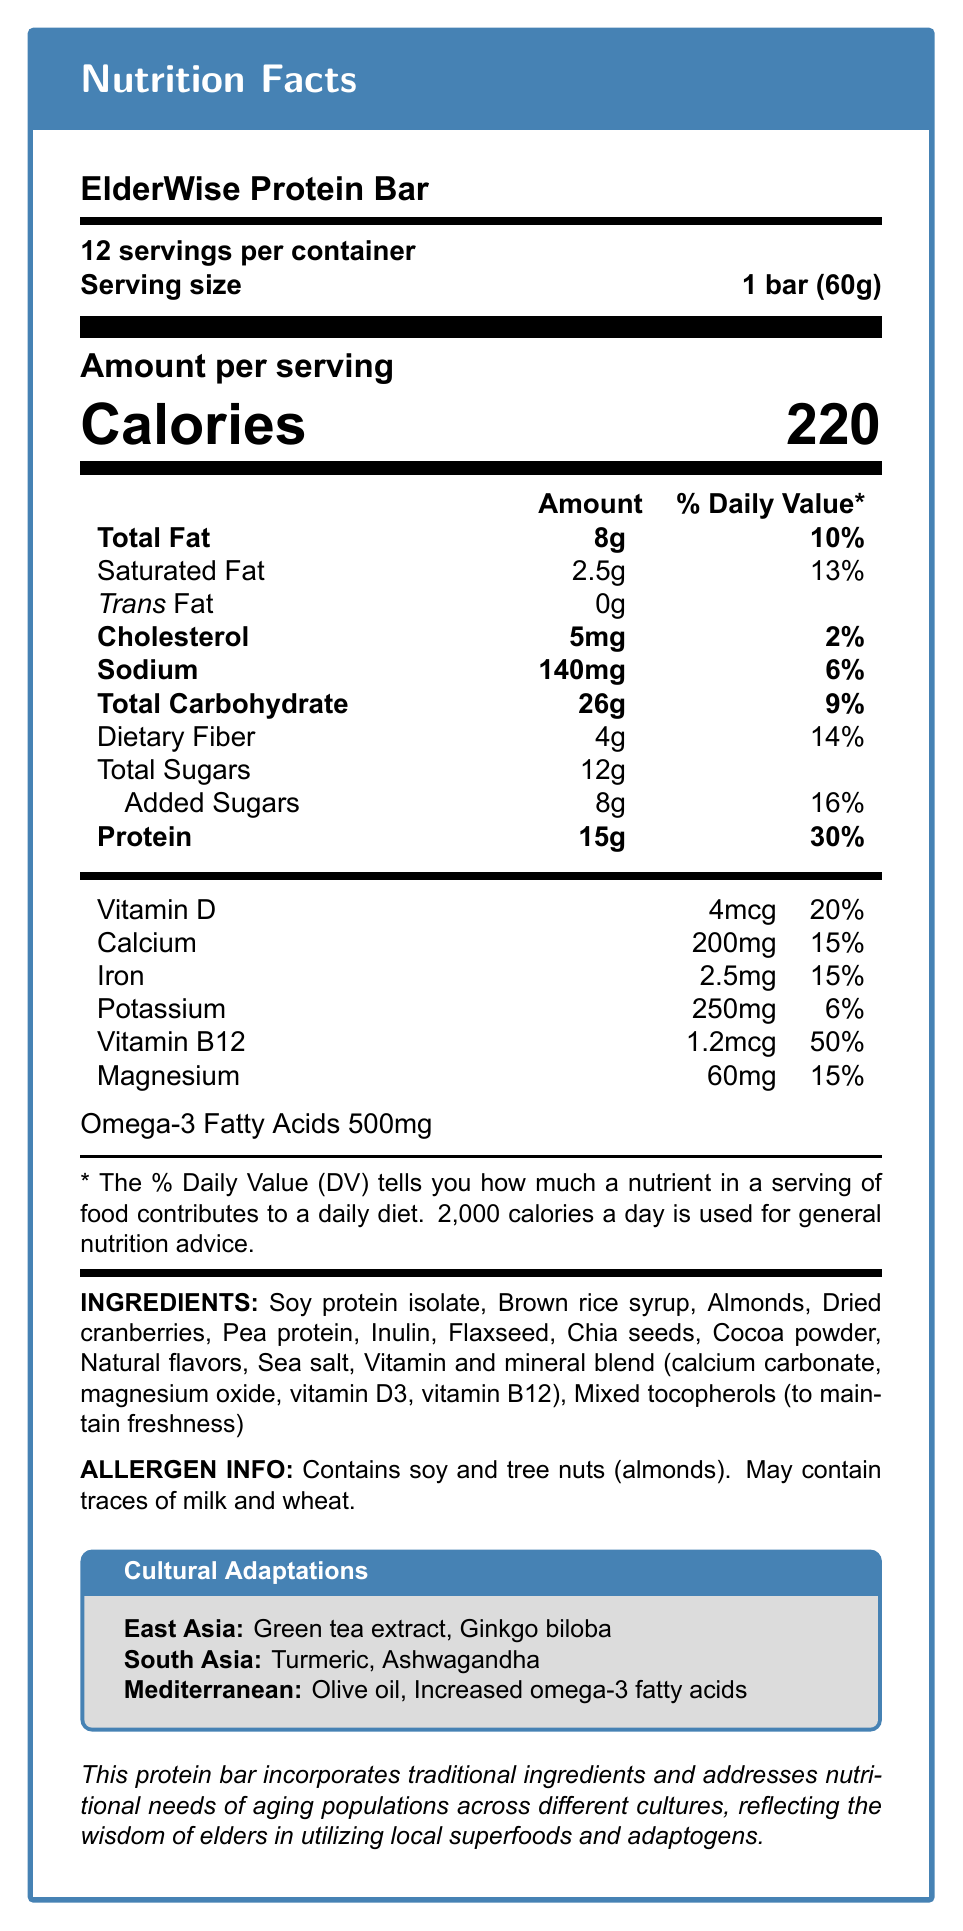what is the serving size of the ElderWise Protein Bar? The serving size is listed as "1 bar (60g)" in the document.
Answer: 1 bar (60g) how many servings are there per container? The document states that there are 12 servings per container.
Answer: 12 what is the total fat content per serving? The amount of total fat per serving is listed as 8g in the document.
Answer: 8g how much protein does each serving provide? The document specifies that each serving contains 15g of protein.
Answer: 15g what are the two allergens mentioned in the document? The allergen information section of the document lists soy and tree nuts (almonds) as allergens.
Answer: Soy and tree nuts (almonds) what are the cultural adaptations made for the East Asia region? The document specifies these adaptations under the cultural adaptations section for the East Asia region.
Answer: Green tea extract added for antioxidant properties, Ginkgo biloba for cognitive support what is the total amount of sugars per serving, including added sugars? The document lists total sugars as 12g and added sugars as 8g.
Answer: 12g total sugars, 8g added sugars what is the percentage of daily value for vitamin B12 per serving? The document states that one serving provides 50% of the daily value for vitamin B12.
Answer: 50% what ingredient is used to maintain freshness? The document lists mixed tocopherols as an ingredient for maintaining freshness.
Answer: Mixed tocopherols how many calories are there in one serving of the ElderWise Protein Bar? The document specifies that one serving contains 220 calories.
Answer: 220 how much cholesterol is in each serving? According to the document, each serving contains 5mg of cholesterol.
Answer: 5mg which adaptation is made for the Mediterranean region? The document specifies the use of olive oil instead of other oils for the Mediterranean region.
Answer: Olive oil used instead of other oils what is the % daily value of iron per serving? The document states that the % daily value of iron per serving is 15%.
Answer: 15% which of the following is an ingredient in the ElderWise Protein Bar?
A. Green tea extract
B. Honey
C. Soy protein isolate The ingredient list in the document includes soy protein isolate. Green tea extract is a regional adaptation for East Asia and honey is not listed.
Answer: C. Soy protein isolate which vitamin is provided in the highest percentage of daily value per serving? 
I. Vitamin D
II. Vitamin B12
III. Calcium The document states that vitamin B12 provides 50% of the daily value, which is higher than the percentages for Vitamin D (20%) and Calcium (15%).
Answer: II. Vitamin B12 does the ElderWise Protein Bar contain any trans fat? The document explicitly states that the trans fat content is 0g.
Answer: No summarize the main idea of the document. The document extensively covers various nutritional details, ingredients, allergens, and cultural modifications to highlight the focus on creating a nutritional product for aging populations across different cultures.
Answer: The ElderWise Protein Bar is a nutritional product aimed at supporting the dietary needs of aging populations, incorporating traditional ingredients and cultural adaptations. It provides detailed nutrition facts, ingredient information, allergen warnings, and regional modifications to cater to different cultural preferences. what is the price per container of the ElderWise Protein Bar? The document does not provide any information regarding the price per container.
Answer: Not enough information 